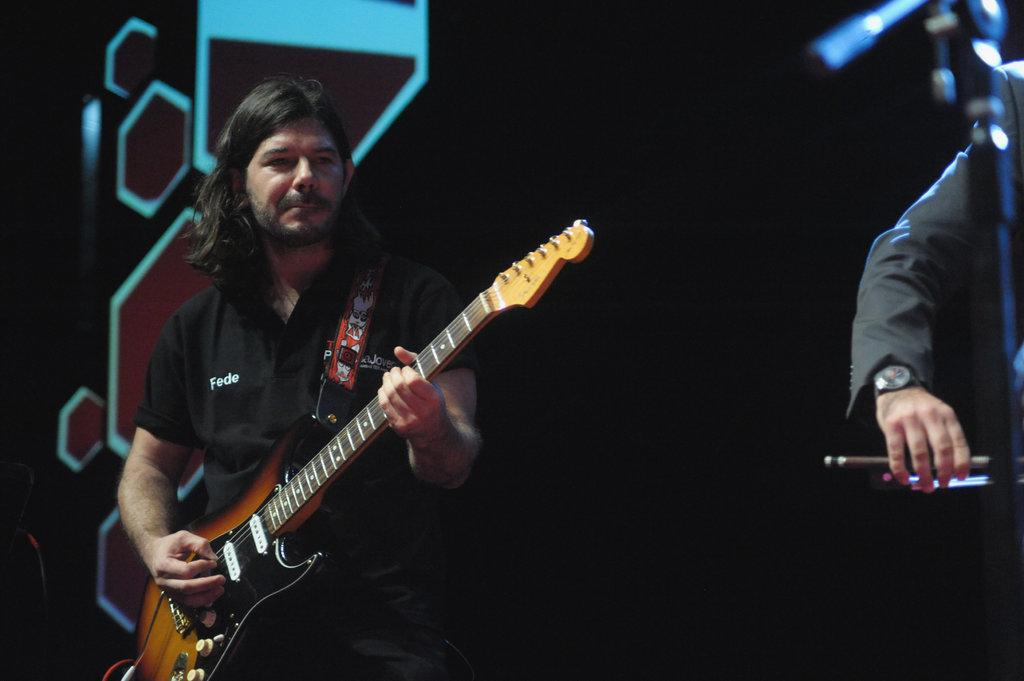What is the main activity being performed in the image? There is a person playing a guitar in the image. Where is the person playing the guitar located in the image? The person playing the guitar is on the left side of the image. What other body part of a person can be seen in the image? There is a person's hand visible in the image. On which side of the image is the person's hand located? The person's hand is on the right side of the image. What type of pest can be seen in the image? There are no pests visible in the image; it features a person playing a guitar and a hand on the right side. 